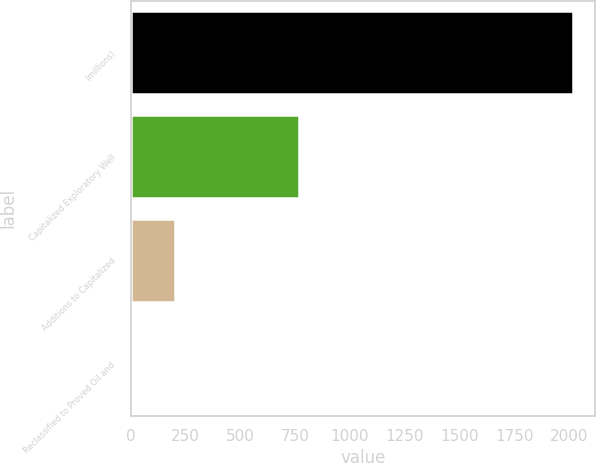Convert chart. <chart><loc_0><loc_0><loc_500><loc_500><bar_chart><fcel>(millions)<fcel>Capitalized Exploratory Well<fcel>Additions to Capitalized<fcel>Reclassified to Proved Oil and<nl><fcel>2016<fcel>768<fcel>202.5<fcel>1<nl></chart> 